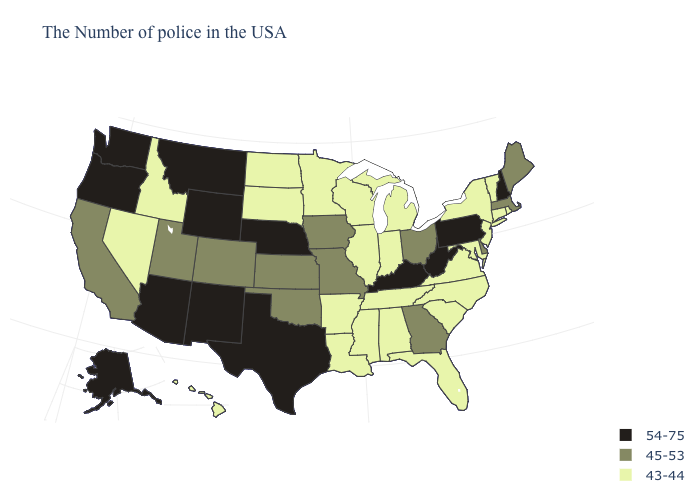Does the first symbol in the legend represent the smallest category?
Answer briefly. No. What is the value of Hawaii?
Give a very brief answer. 43-44. Name the states that have a value in the range 54-75?
Give a very brief answer. New Hampshire, Pennsylvania, West Virginia, Kentucky, Nebraska, Texas, Wyoming, New Mexico, Montana, Arizona, Washington, Oregon, Alaska. What is the highest value in the USA?
Give a very brief answer. 54-75. Name the states that have a value in the range 45-53?
Short answer required. Maine, Massachusetts, Delaware, Ohio, Georgia, Missouri, Iowa, Kansas, Oklahoma, Colorado, Utah, California. Name the states that have a value in the range 43-44?
Keep it brief. Rhode Island, Vermont, Connecticut, New York, New Jersey, Maryland, Virginia, North Carolina, South Carolina, Florida, Michigan, Indiana, Alabama, Tennessee, Wisconsin, Illinois, Mississippi, Louisiana, Arkansas, Minnesota, South Dakota, North Dakota, Idaho, Nevada, Hawaii. What is the value of Hawaii?
Keep it brief. 43-44. Does West Virginia have the highest value in the USA?
Write a very short answer. Yes. What is the highest value in the Northeast ?
Give a very brief answer. 54-75. Which states have the highest value in the USA?
Be succinct. New Hampshire, Pennsylvania, West Virginia, Kentucky, Nebraska, Texas, Wyoming, New Mexico, Montana, Arizona, Washington, Oregon, Alaska. Name the states that have a value in the range 43-44?
Write a very short answer. Rhode Island, Vermont, Connecticut, New York, New Jersey, Maryland, Virginia, North Carolina, South Carolina, Florida, Michigan, Indiana, Alabama, Tennessee, Wisconsin, Illinois, Mississippi, Louisiana, Arkansas, Minnesota, South Dakota, North Dakota, Idaho, Nevada, Hawaii. What is the lowest value in the USA?
Concise answer only. 43-44. Does Kentucky have the lowest value in the USA?
Concise answer only. No. Name the states that have a value in the range 54-75?
Concise answer only. New Hampshire, Pennsylvania, West Virginia, Kentucky, Nebraska, Texas, Wyoming, New Mexico, Montana, Arizona, Washington, Oregon, Alaska. Is the legend a continuous bar?
Short answer required. No. 